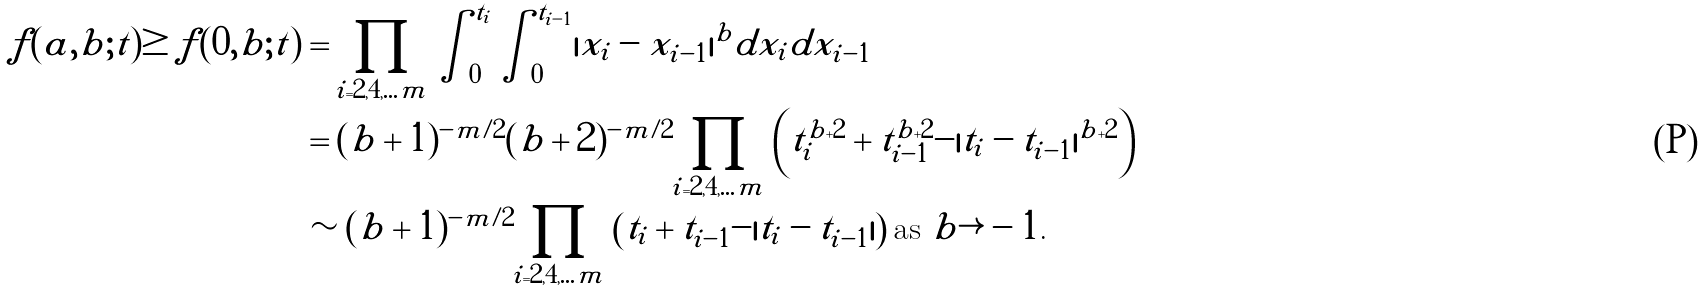Convert formula to latex. <formula><loc_0><loc_0><loc_500><loc_500>f ( a , b ; t ) \geq f ( 0 , b ; t ) & = \prod _ { i = 2 , 4 , \dots m } \int _ { 0 } ^ { t _ { i } } \int _ { 0 } ^ { t _ { i - 1 } } | x _ { i } - x _ { i - 1 } | ^ { b } d x _ { i } d x _ { i - 1 } \\ & = ( b + 1 ) ^ { - m / 2 } ( b + 2 ) ^ { - m / 2 } \prod _ { i = 2 , 4 , \dots m } \left ( t _ { i } ^ { b + 2 } + t _ { i - 1 } ^ { b + 2 } - | t _ { i } - t _ { i - 1 } | ^ { b + 2 } \right ) \\ & \sim ( b + 1 ) ^ { - m / 2 } \prod _ { i = 2 , 4 , \dots m } \left ( t _ { i } + t _ { i - 1 } - | t _ { i } - t _ { i - 1 } | \right ) \text {as $b\rightarrow -1$.}</formula> 